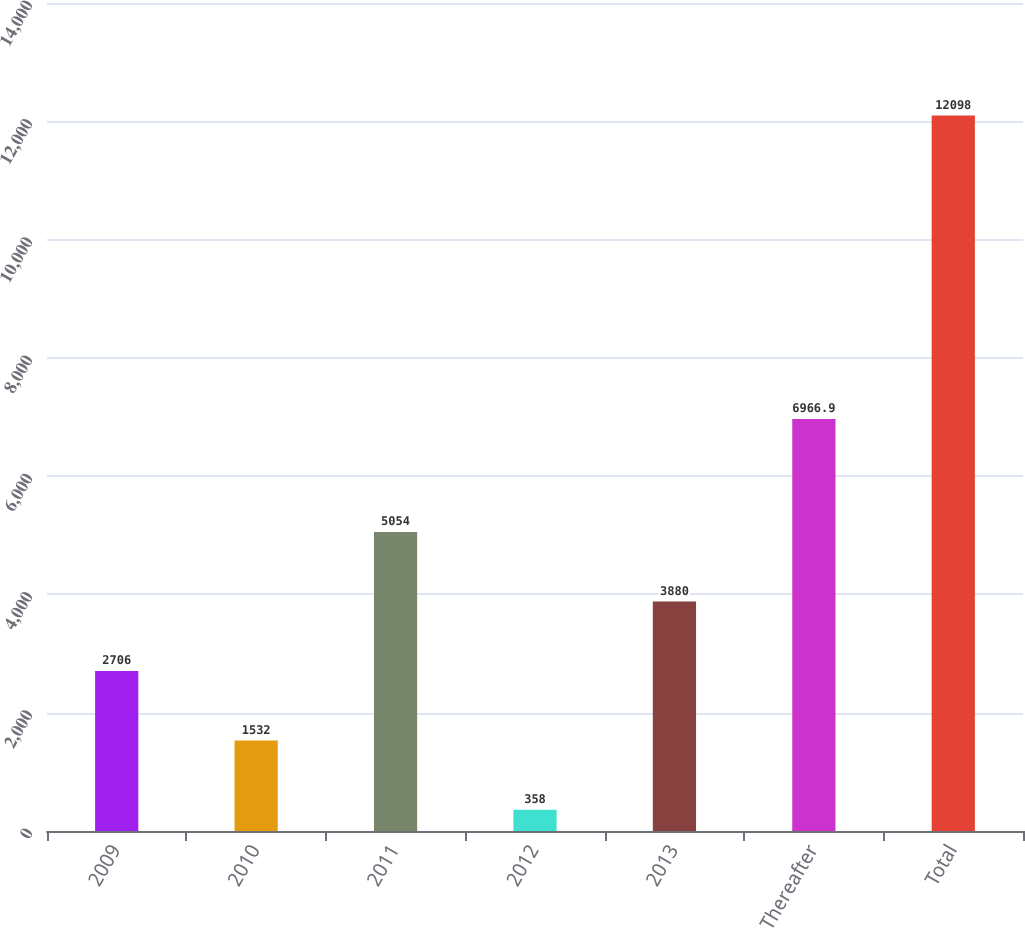Convert chart. <chart><loc_0><loc_0><loc_500><loc_500><bar_chart><fcel>2009<fcel>2010<fcel>2011<fcel>2012<fcel>2013<fcel>Thereafter<fcel>Total<nl><fcel>2706<fcel>1532<fcel>5054<fcel>358<fcel>3880<fcel>6966.9<fcel>12098<nl></chart> 